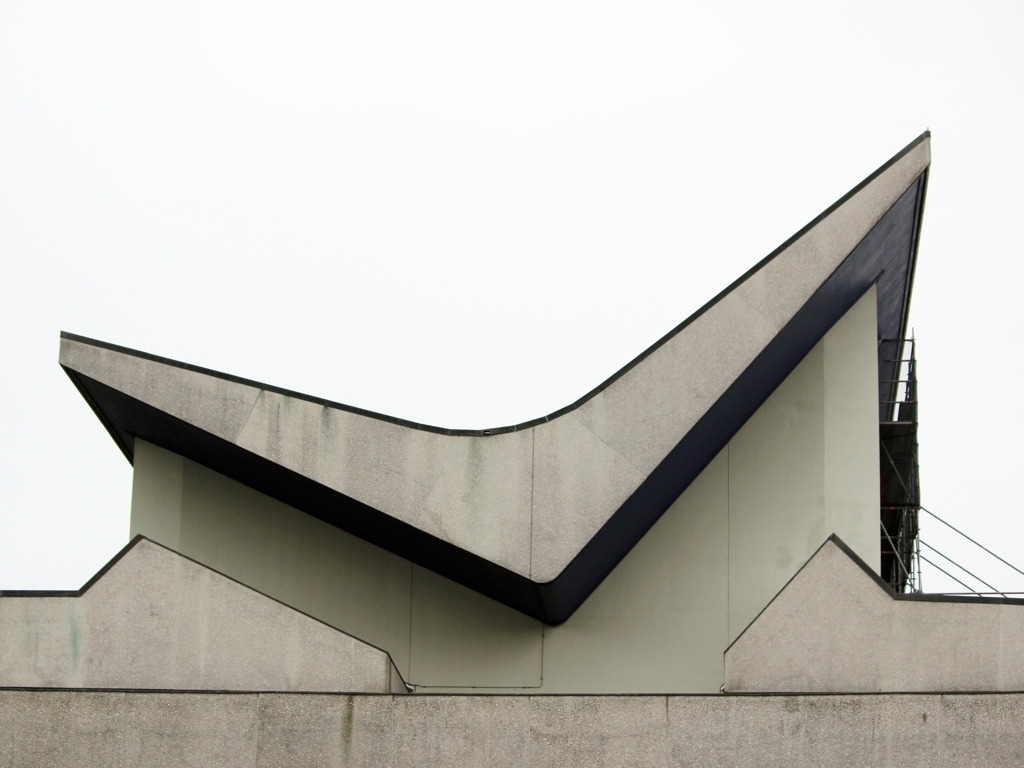Is the foreground properly exposed? The foreground appears to be slightly underexposed. The details and texture of the building's facade are not as clear or as bright as they could be with a more balanced exposure. Adjusting exposure settings could bring out more of the architectural elements and enhance the overall composition of the photo. 